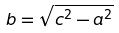Convert formula to latex. <formula><loc_0><loc_0><loc_500><loc_500>b = \sqrt { c ^ { 2 } - a ^ { 2 } }</formula> 